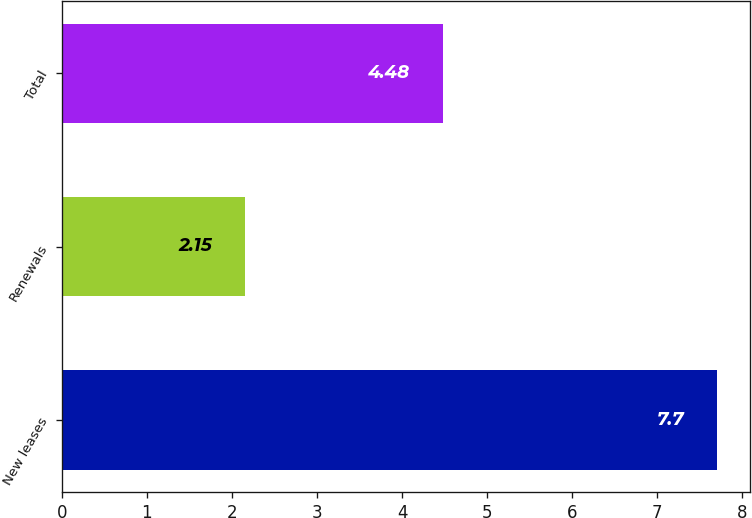Convert chart. <chart><loc_0><loc_0><loc_500><loc_500><bar_chart><fcel>New leases<fcel>Renewals<fcel>Total<nl><fcel>7.7<fcel>2.15<fcel>4.48<nl></chart> 